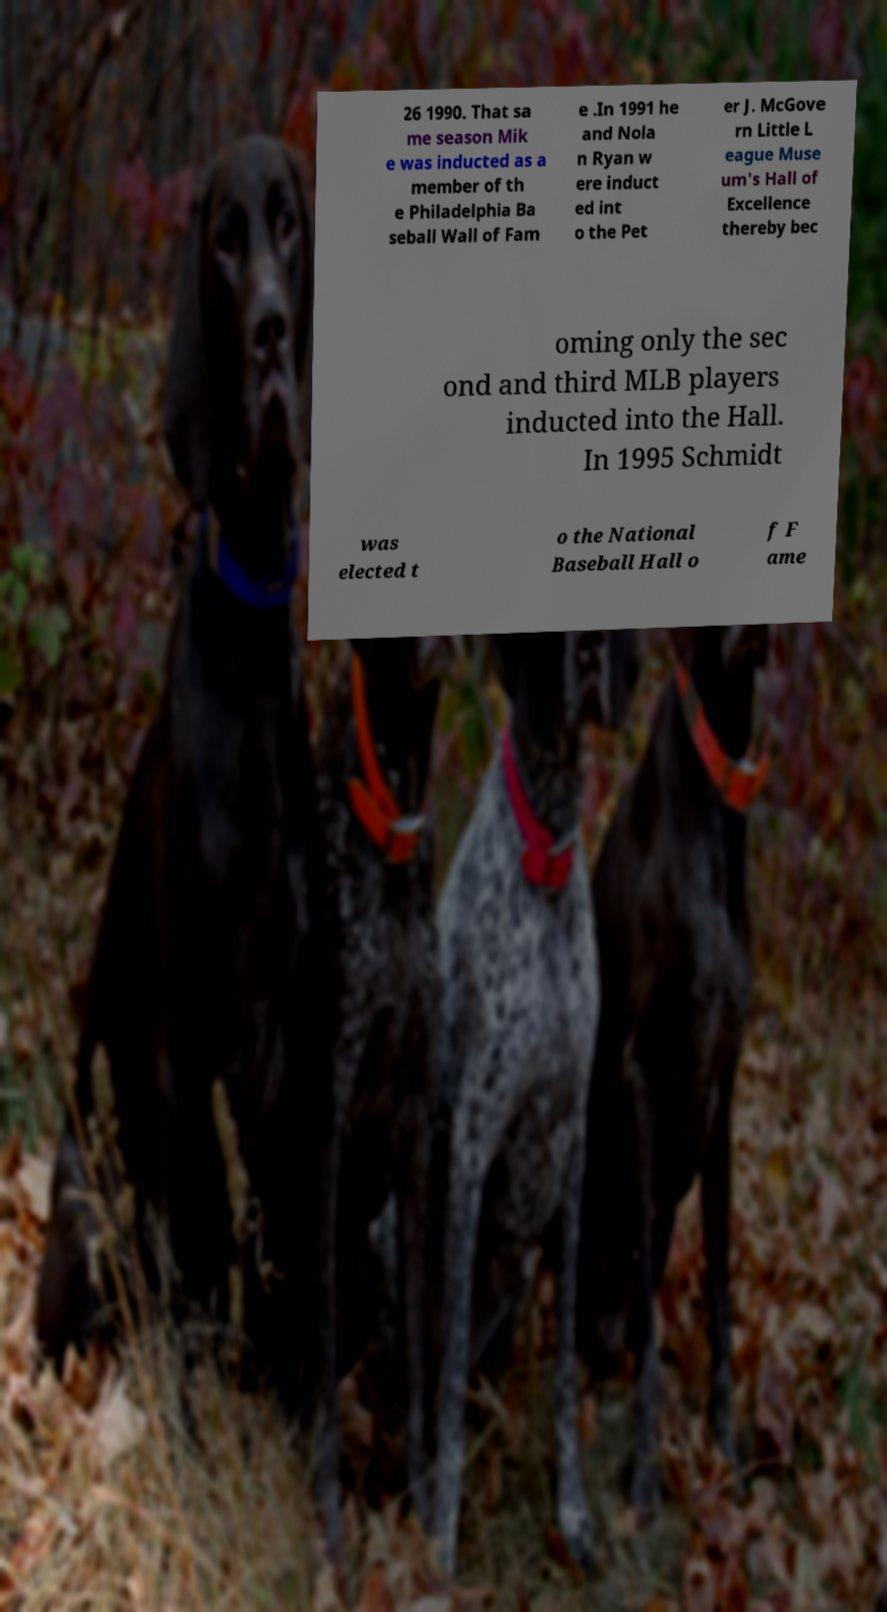Could you assist in decoding the text presented in this image and type it out clearly? 26 1990. That sa me season Mik e was inducted as a member of th e Philadelphia Ba seball Wall of Fam e .In 1991 he and Nola n Ryan w ere induct ed int o the Pet er J. McGove rn Little L eague Muse um's Hall of Excellence thereby bec oming only the sec ond and third MLB players inducted into the Hall. In 1995 Schmidt was elected t o the National Baseball Hall o f F ame 